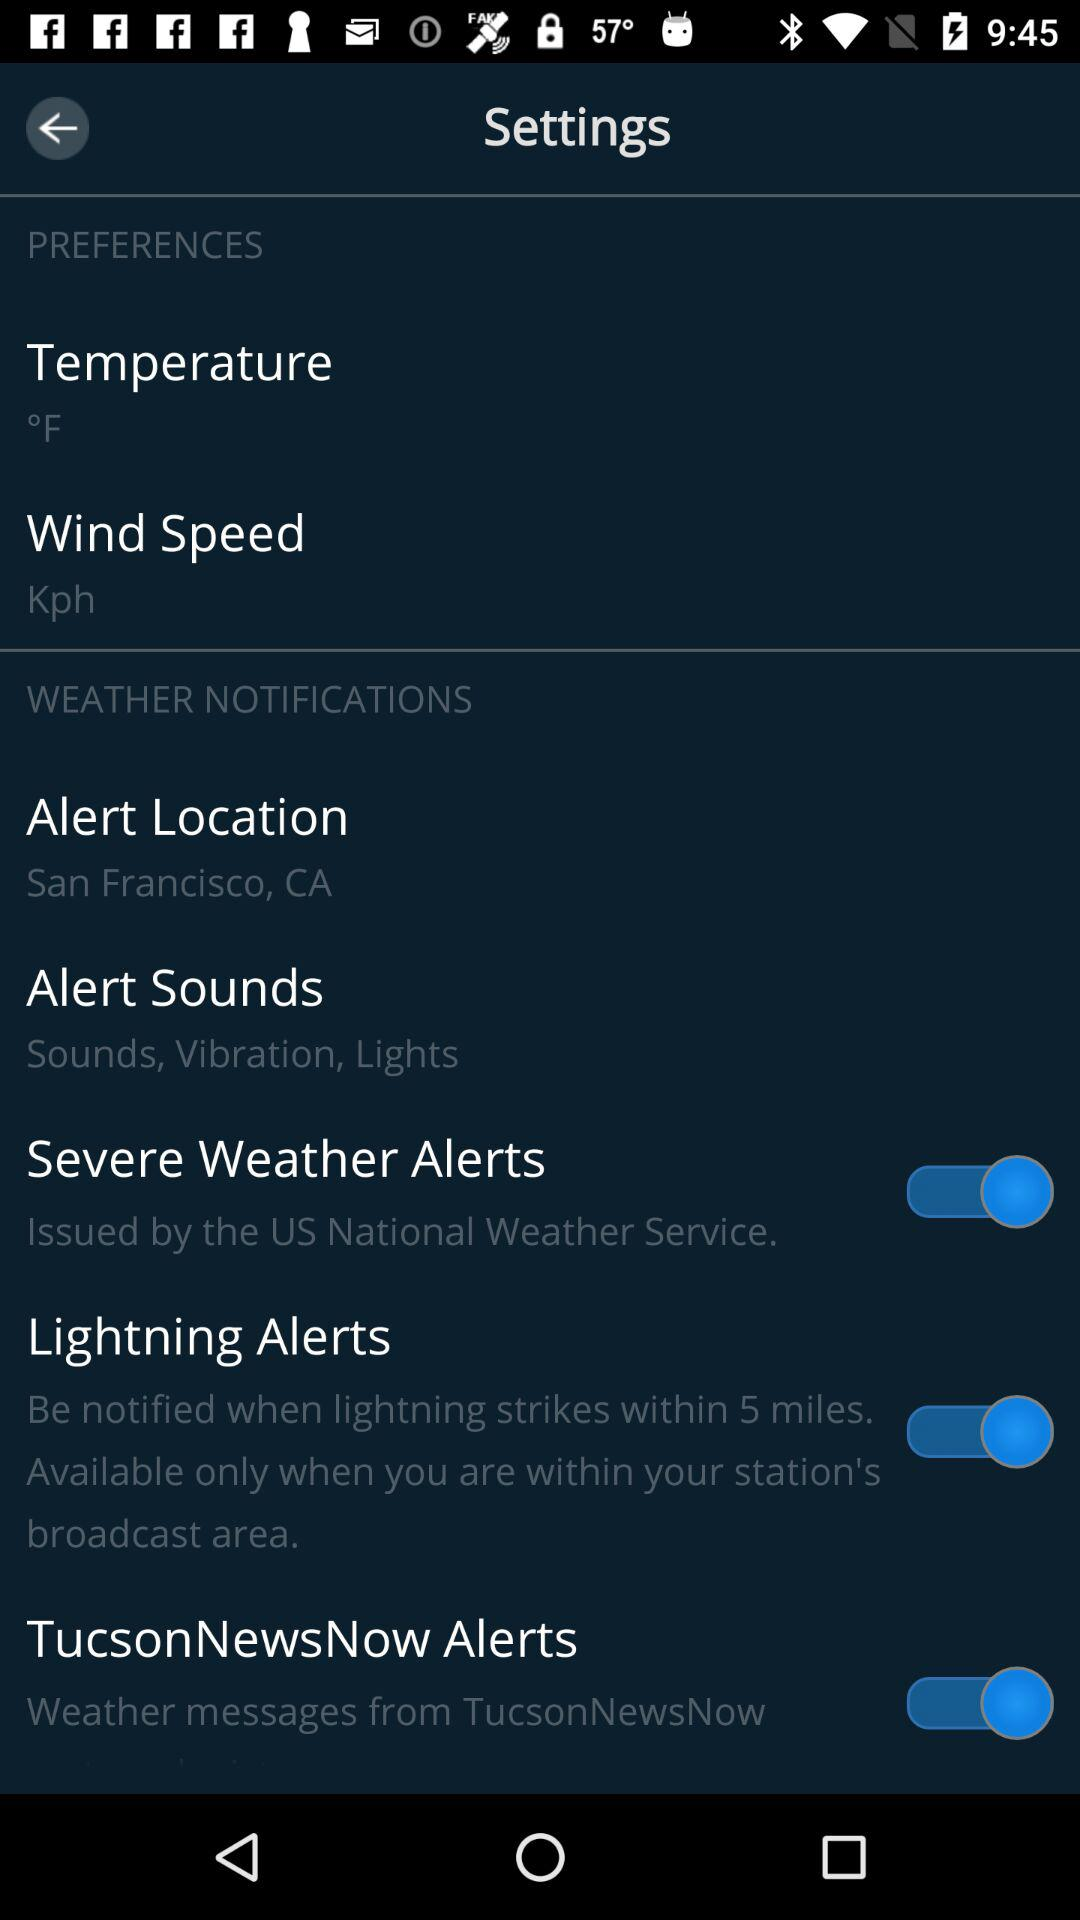What is the setting for the alert sound? The setting is "Sounds, Vibration, Lights". 